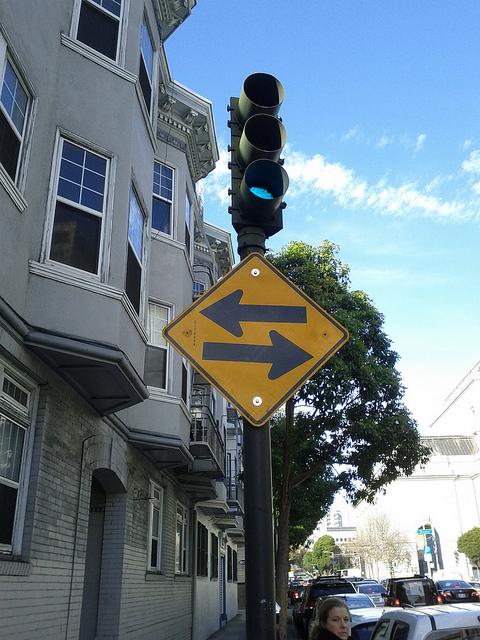What color is the light?
Write a very short answer. Green. Is the neighborhood old or new?
Be succinct. Old. What color of light is on?
Quick response, please. Green. What is the color of the sign?
Give a very brief answer. Yellow. Would you be able to shop in this area?
Quick response, please. No. What does the yellow sign mean?
Give a very brief answer. Two way traffic. 